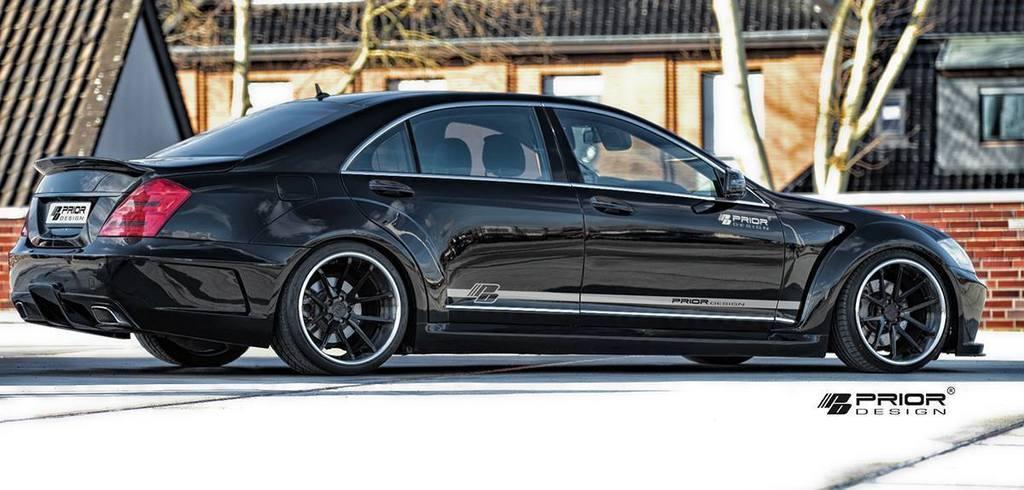In one or two sentences, can you explain what this image depicts? This image consists of a car in black color. At the bottom, there is a road. In the background, we can see a house along with windows and trees. 